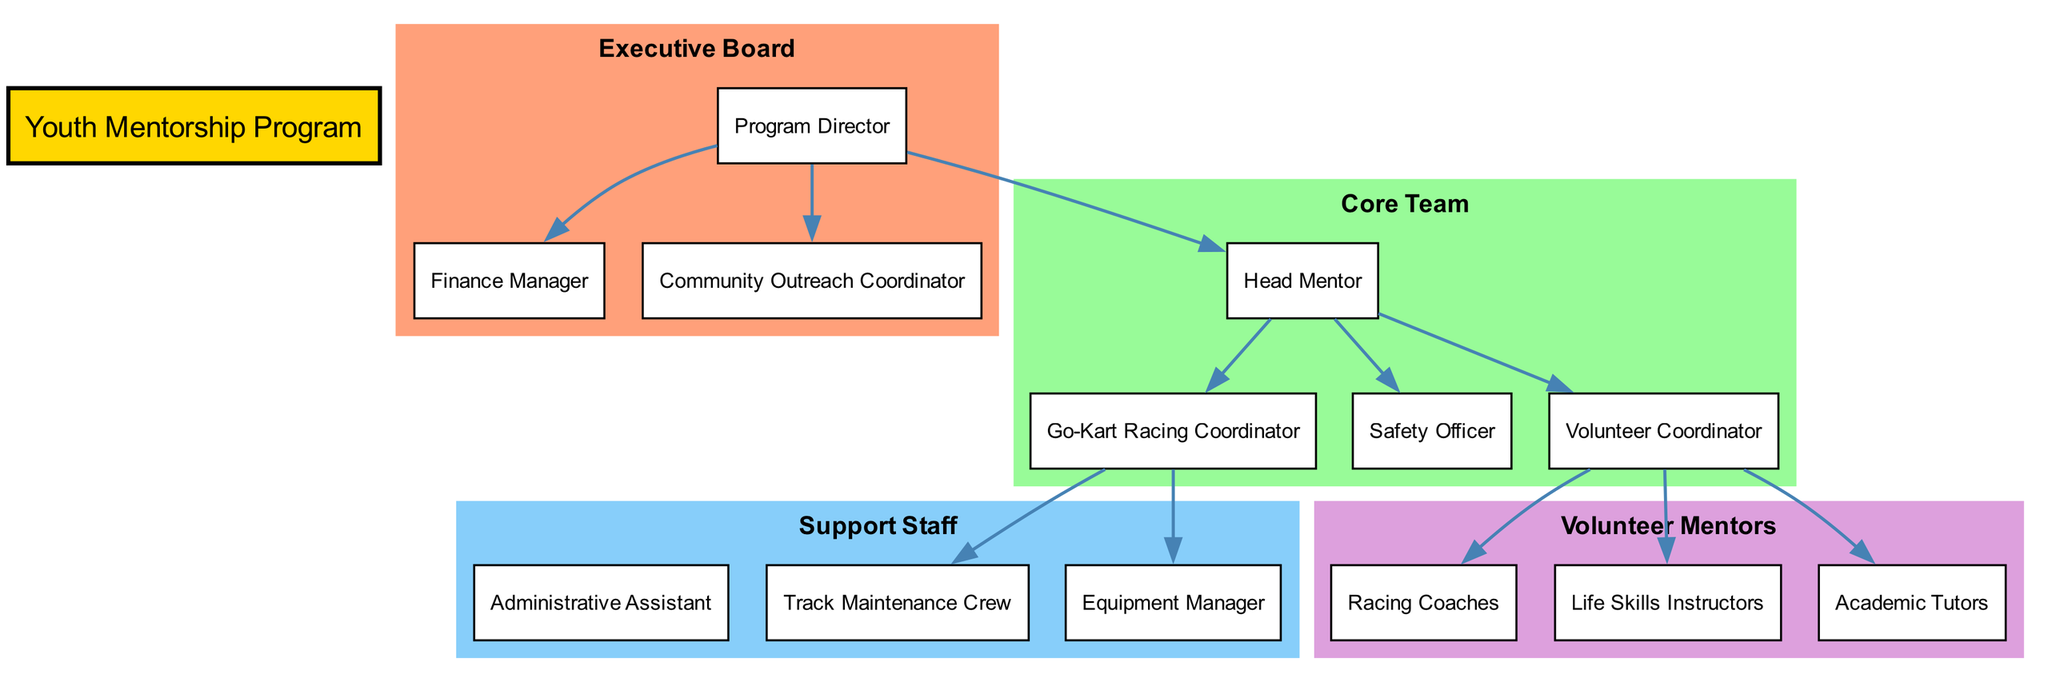What is the top role in the organizational chart? The top role, or root node, is labeled "Youth Mentorship Program," indicating that it is the primary structure of the organization's hierarchy.
Answer: Youth Mentorship Program How many levels are in the organizational structure? There are four levels in the diagram as indicated by the distinct groupings: Executive Board, Core Team, Support Staff, and Volunteer Mentors.
Answer: 4 Who does the Program Director report to? The Program Director is at the top level, reporting directly to itself; hence, it has no superior node in this structure.
Answer: N/A What is the duty of the Go-Kart Racing Coordinator? The specific duty of the Go-Kart Racing Coordinator is detailed as "Event planning, race schedules, track management," indicating their main responsibilities.
Answer: Event planning, race schedules, track management Which roles fall under the Head Mentor? Under the Head Mentor, the roles specified are the Go-Kart Racing Coordinator, Safety Officer, and Volunteer Coordinator, showing a direct reporting structure.
Answer: Go-Kart Racing Coordinator, Safety Officer, Volunteer Coordinator How many individual nodes are there in the Support Staff level? The Support Staff level has three nodes: Administrative Assistant, Track Maintenance Crew, and Equipment Manager, which can be counted directly from the level definition.
Answer: 3 What are the responsibilities of the Volunteer Coordinator? The responsibilities of the Volunteer Coordinator are stated as "Recruit and manage volunteer mentors," outlining the duties expected from this role.
Answer: Recruit and manage volunteer mentors Which node directly connects to the Racing Coaches? The node that directly connects to the Racing Coaches is the Volunteer Coordinator, showing it as a direct report in the mentoring program structure.
Answer: Volunteer Coordinator How many connections originate from the Head Mentor? There are three connections originating from the Head Mentor: to the Go-Kart Racing Coordinator, Safety Officer, and Volunteer Coordinator, which can be tracked within the diagram's connections.
Answer: 3 